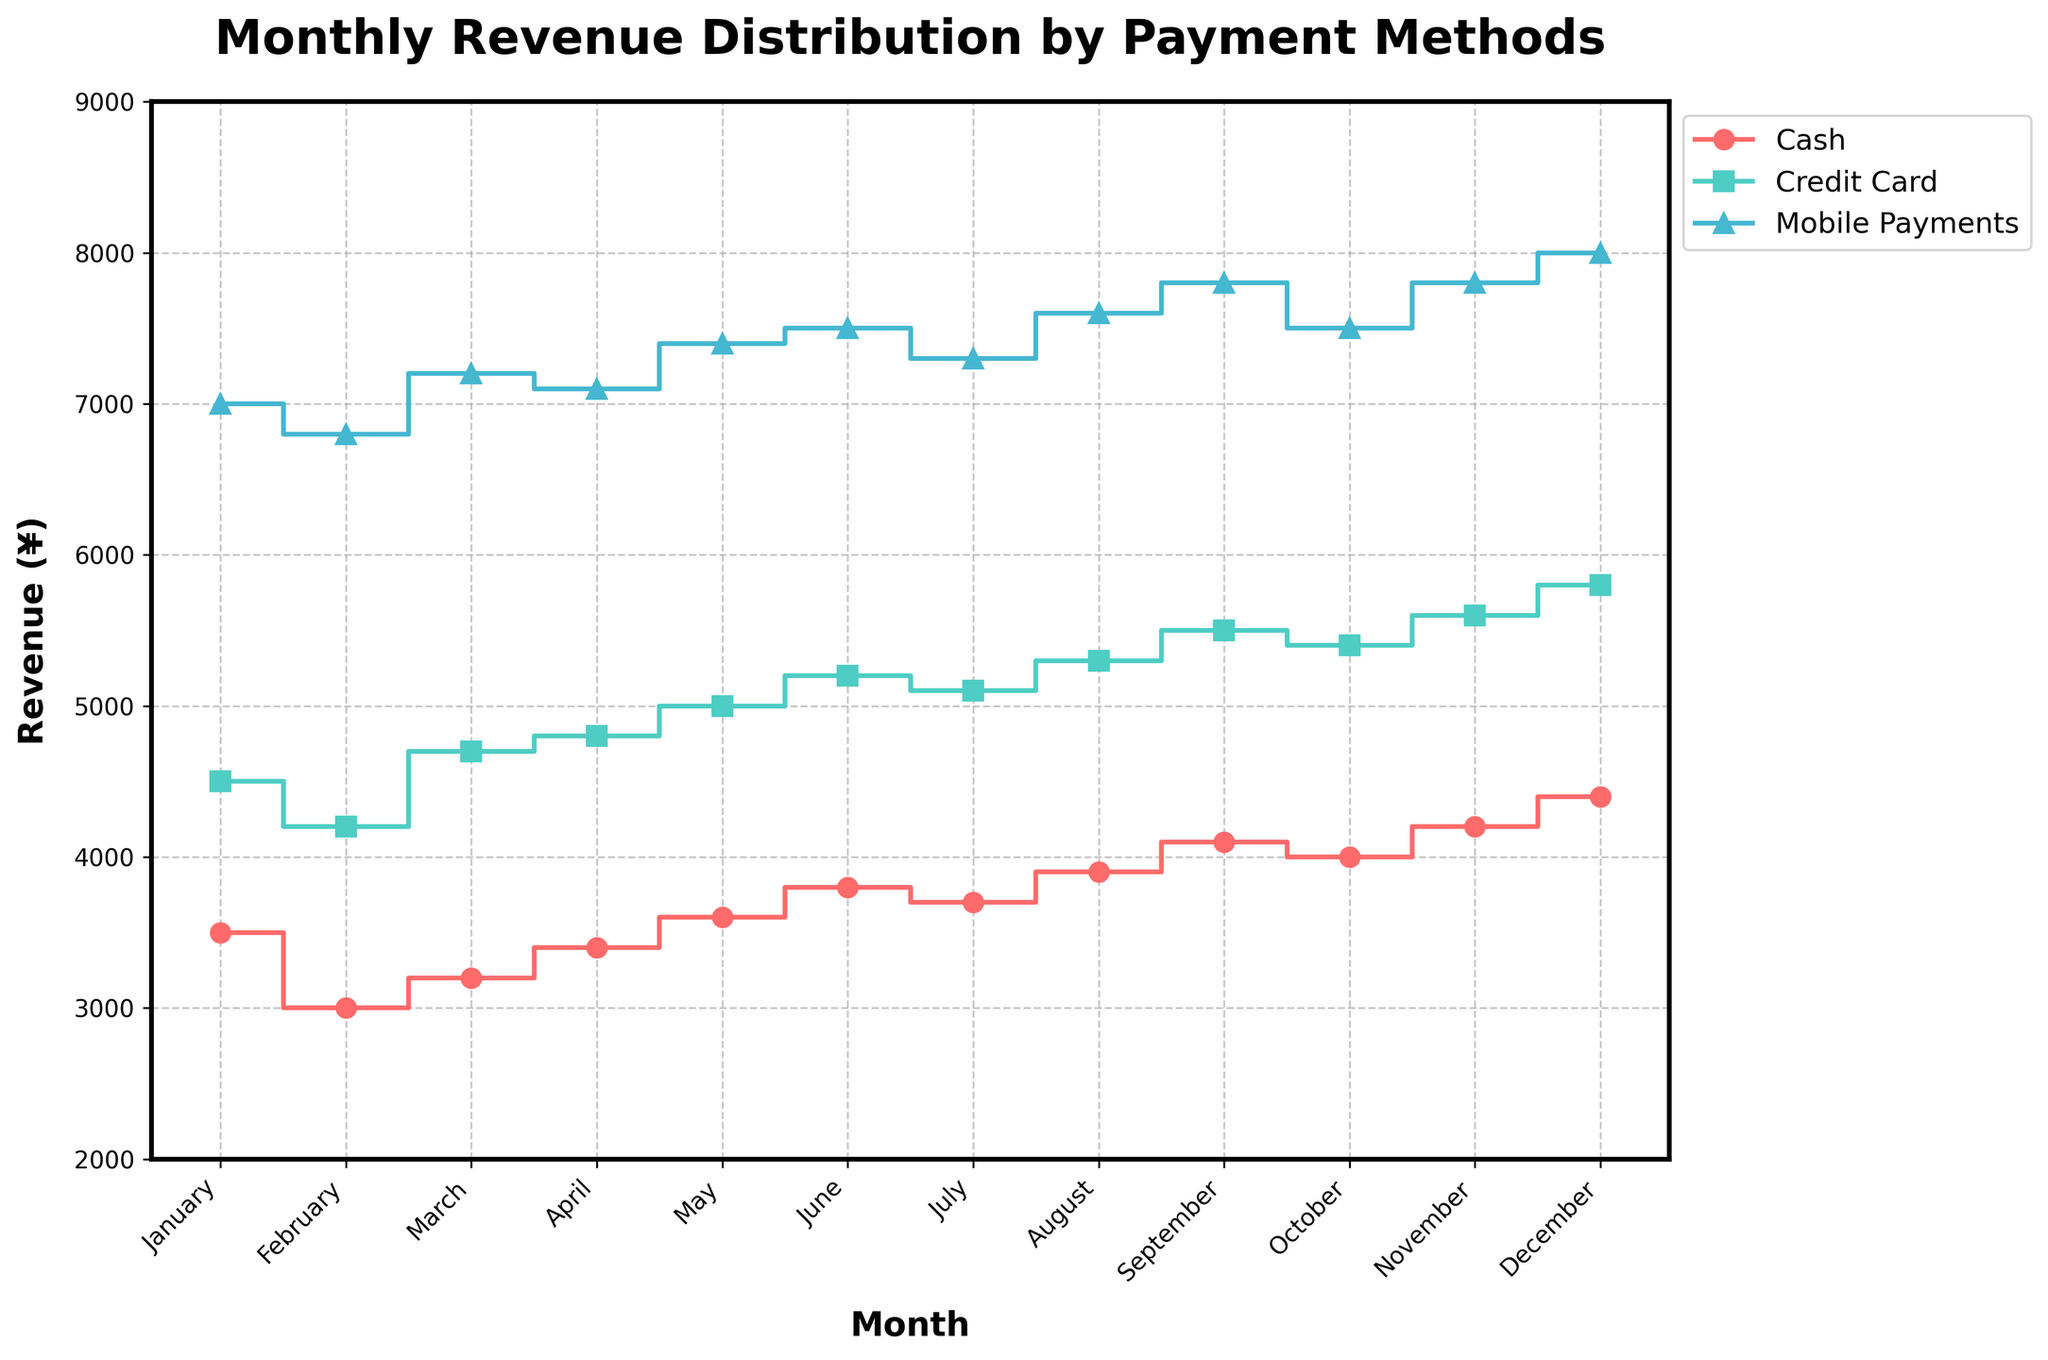What is the title of the plot? The title is located at the top of the figure and it reads 'Monthly Revenue Distribution by Payment Methods'.
Answer: Monthly Revenue Distribution by Payment Methods How much was the revenue from cash payments in January? Locate the 'January' label on the x-axis and follow the line to the 'Cash' stair plot, which is marked with circular markers. The corresponding y-value shows the revenue.
Answer: 3500 Which month had the highest revenue from Mobile Payments? Inspect the stair plot for Mobile Payments, identified by triangular markers, and look for the highest y-value. This value is reached in December.
Answer: December What is the average revenue from Credit Card payments across all months? Add up all monthly Credit Card revenues (4500 + 4200 + 4700 + 4800 + 5000 + 5200 + 5100 + 5300 + 5500 + 5400 + 5600 + 5800) and divide by the number of months (12).
Answer: 5025 Did the revenue from Cash payments increase or decrease from February to March? Compare the y-values of the Cash stair plot between February (3000) and March (3200). The revenue increased.
Answer: Increase What is the total revenue in June combining all payment methods? Sum up the values for June from each payment method: Cash (3800), Credit Card (5200), and Mobile Payments (7500).
Answer: 16500 Which payment method had the least variation in monthly revenue? Inspect the range of y-values for each payment method. Cash payments range from 3000 to 4400, Credit Card payments from 4200 to 5800, and Mobile Payments from 6800 to 8000, indicating that Cash has the least variation.
Answer: Cash How does the revenue from Mobile Payments in July compare to that in August? Locate the points for Mobile Payments in July (7300) and August (7600) and compare their y-values. Revenue increased in August.
Answer: Increased What is the difference in total revenue between November and December for all payment methods combined? Sum the revenue for each payment method in November (4200 + 5600 + 7800 = 17600) and December (4400 + 5800 + 8000 = 18200) and subtract the November total from the December total (18200 - 17600).
Answer: 600 In which month did Credit Card payments exceed Cash payments by the greatest margin? Calculate the difference between Credit Card and Cash payments for each month and find the maximum difference: 
January (1000), February (1200), March (1500), April (1400), May (1400), June (1400), July (1400), August (1400), September (1400), October (1400), November (1400), December (1400). March has the greatest margin.
Answer: March 